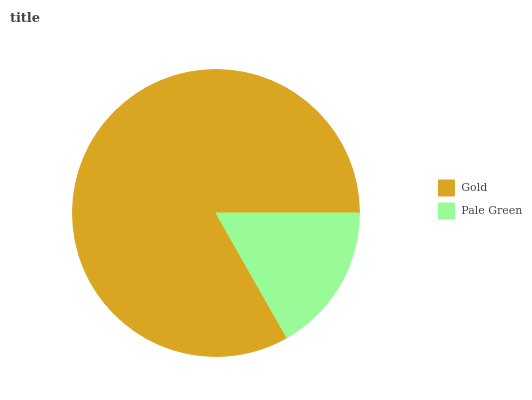Is Pale Green the minimum?
Answer yes or no. Yes. Is Gold the maximum?
Answer yes or no. Yes. Is Pale Green the maximum?
Answer yes or no. No. Is Gold greater than Pale Green?
Answer yes or no. Yes. Is Pale Green less than Gold?
Answer yes or no. Yes. Is Pale Green greater than Gold?
Answer yes or no. No. Is Gold less than Pale Green?
Answer yes or no. No. Is Gold the high median?
Answer yes or no. Yes. Is Pale Green the low median?
Answer yes or no. Yes. Is Pale Green the high median?
Answer yes or no. No. Is Gold the low median?
Answer yes or no. No. 